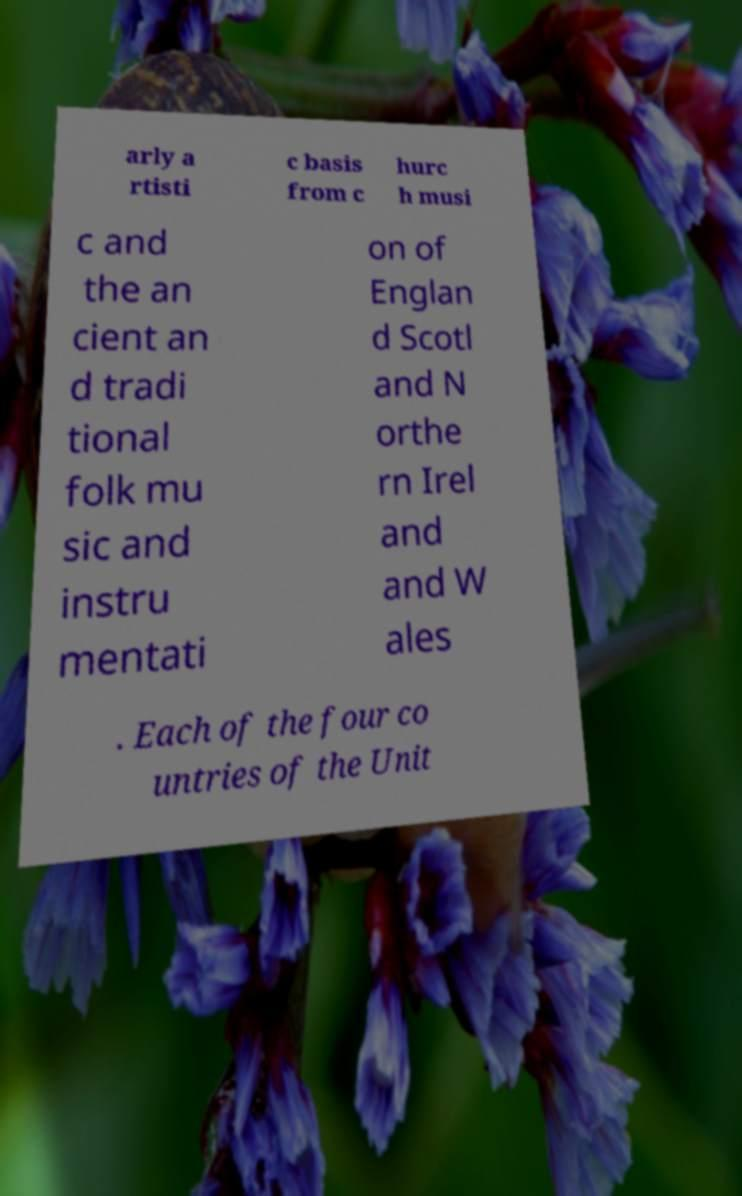Could you extract and type out the text from this image? arly a rtisti c basis from c hurc h musi c and the an cient an d tradi tional folk mu sic and instru mentati on of Englan d Scotl and N orthe rn Irel and and W ales . Each of the four co untries of the Unit 